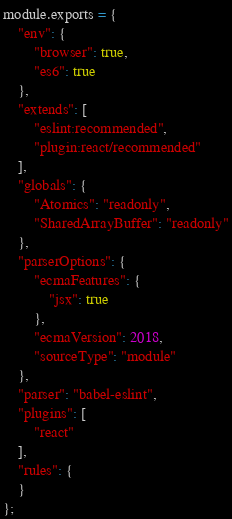Convert code to text. <code><loc_0><loc_0><loc_500><loc_500><_JavaScript_>module.exports = {
    "env": {
        "browser": true,
        "es6": true
    },
    "extends": [
        "eslint:recommended",
        "plugin:react/recommended"
    ],
    "globals": {
        "Atomics": "readonly",
        "SharedArrayBuffer": "readonly"
    },
    "parserOptions": {
        "ecmaFeatures": {
            "jsx": true
        },
        "ecmaVersion": 2018,
        "sourceType": "module"
    },
    "parser": "babel-eslint",
    "plugins": [
        "react"
    ],
    "rules": {
    }
};
</code> 